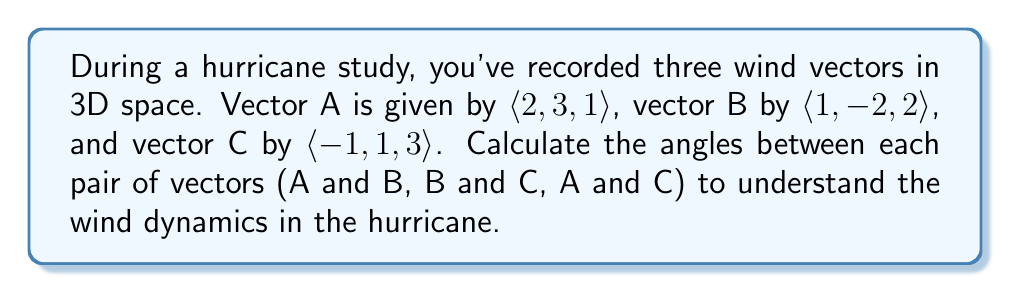Give your solution to this math problem. To find the angles between pairs of vectors in 3D space, we'll use the dot product formula:

$$\cos \theta = \frac{\mathbf{a} \cdot \mathbf{b}}{|\mathbf{a}||\mathbf{b}|}$$

Where $\theta$ is the angle between vectors $\mathbf{a}$ and $\mathbf{b}$, and $|\mathbf{a}|$ and $|\mathbf{b}|$ are the magnitudes of the vectors.

1. For vectors A and B:

   $\mathbf{A} \cdot \mathbf{B} = (2)(1) + (3)(-2) + (1)(2) = 2 - 6 + 2 = -2$
   
   $|\mathbf{A}| = \sqrt{2^2 + 3^2 + 1^2} = \sqrt{14}$
   
   $|\mathbf{B}| = \sqrt{1^2 + (-2)^2 + 2^2} = 3$

   $$\cos \theta_{AB} = \frac{-2}{\sqrt{14} \cdot 3} = -\frac{2}{3\sqrt{14}}$$

   $\theta_{AB} = \arccos(-\frac{2}{3\sqrt{14}}) \approx 1.9351$ radians or $110.89°$

2. For vectors B and C:

   $\mathbf{B} \cdot \mathbf{C} = (1)(-1) + (-2)(1) + (2)(3) = -1 - 2 + 6 = 3$
   
   $|\mathbf{B}| = 3$ (calculated earlier)
   
   $|\mathbf{C}| = \sqrt{(-1)^2 + 1^2 + 3^2} = \sqrt{11}$

   $$\cos \theta_{BC} = \frac{3}{3 \cdot \sqrt{11}} = \frac{1}{\sqrt{11}}$$

   $\theta_{BC} = \arccos(\frac{1}{\sqrt{11}}) \approx 1.2490$ radians or $71.57°$

3. For vectors A and C:

   $\mathbf{A} \cdot \mathbf{C} = (2)(-1) + (3)(1) + (1)(3) = -2 + 3 + 3 = 4$
   
   $|\mathbf{A}| = \sqrt{14}$ (calculated earlier)
   
   $|\mathbf{C}| = \sqrt{11}$ (calculated earlier)

   $$\cos \theta_{AC} = \frac{4}{\sqrt{14} \cdot \sqrt{11}} = \frac{4}{\sqrt{154}}$$

   $\theta_{AC} = \arccos(\frac{4}{\sqrt{154}}) \approx 1.1071$ radians or $63.43°$
Answer: The angles between the wind vectors are:
A and B: $110.89°$
B and C: $71.57°$
A and C: $63.43°$ 